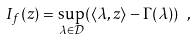Convert formula to latex. <formula><loc_0><loc_0><loc_500><loc_500>I _ { f } ( z ) = \sup _ { \lambda \in { \mathcal { D } } } ( \langle \lambda , z \rangle - \Gamma ( \lambda ) ) \ ,</formula> 